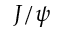Convert formula to latex. <formula><loc_0><loc_0><loc_500><loc_500>J / \psi</formula> 